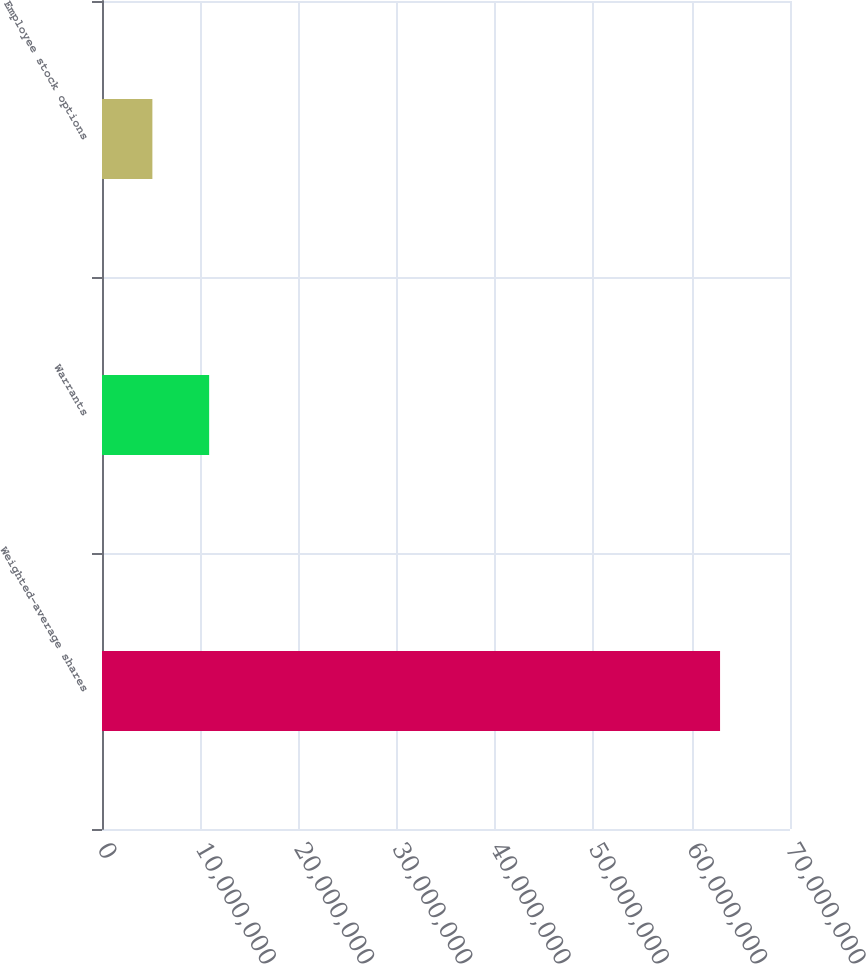<chart> <loc_0><loc_0><loc_500><loc_500><bar_chart><fcel>Weighted-average shares<fcel>Warrants<fcel>Employee stock options<nl><fcel>6.2884e+07<fcel>1.09018e+07<fcel>5.126e+06<nl></chart> 